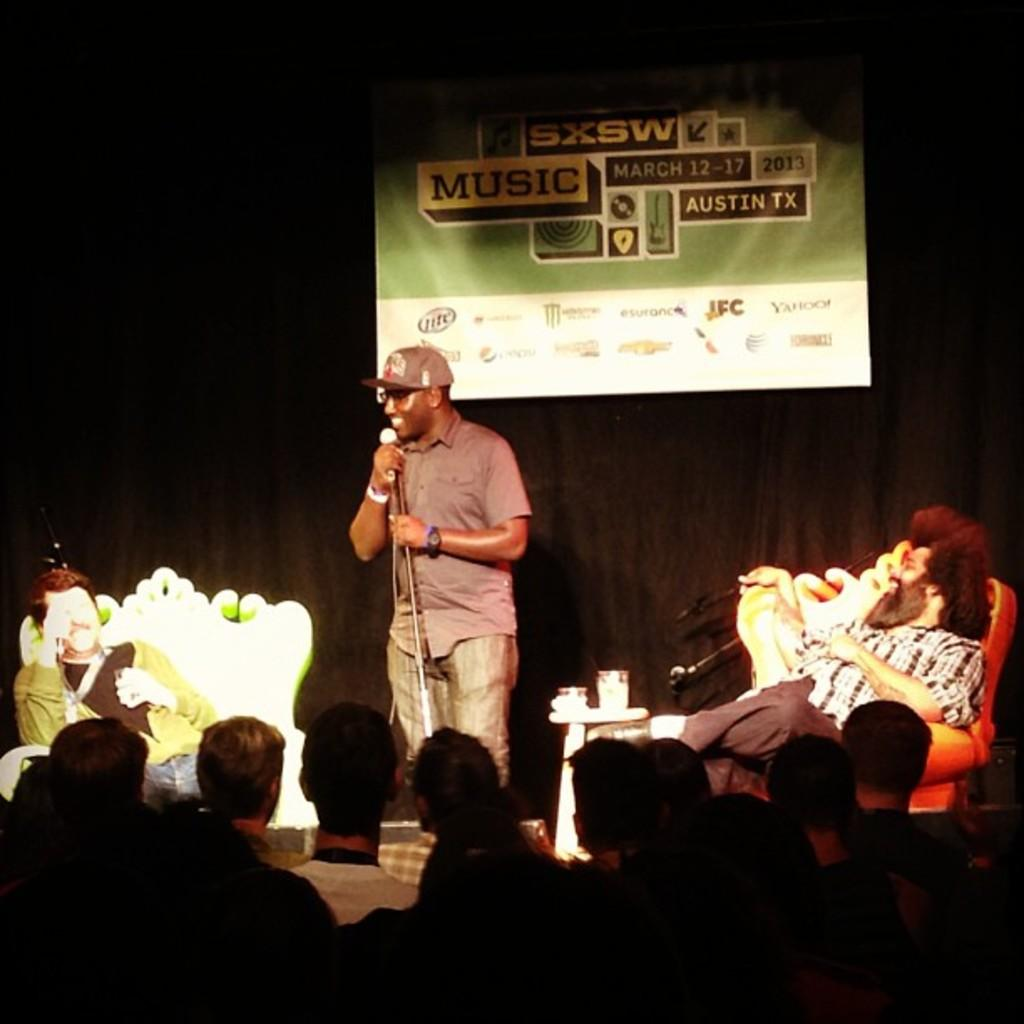How many persons can be seen in the image? There are persons in the image, but the exact number is not specified. What object is present that is typically used for amplifying sound? There is a microphone in the image. What type of furniture is visible in the image? There are chairs in the image. What can be seen in the background of the image? There is a wall, a name board, and other objects in the background of the image. What type of skirt is the person wearing in the image? There is no information about a skirt or any clothing in the image. Is there any indication of an attack happening in the image? No, there is no indication of an attack or any violent activity in the image. 